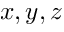Convert formula to latex. <formula><loc_0><loc_0><loc_500><loc_500>x , y , z</formula> 